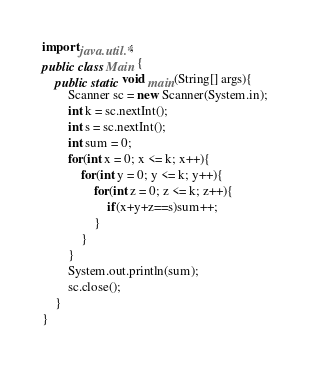<code> <loc_0><loc_0><loc_500><loc_500><_Java_>import java.util.*;
public class Main {
    public static void main(String[] args){
        Scanner sc = new Scanner(System.in);
        int k = sc.nextInt();
        int s = sc.nextInt();
        int sum = 0;
        for(int x = 0; x <= k; x++){
            for(int y = 0; y <= k; y++){
                for(int z = 0; z <= k; z++){
                    if(x+y+z==s)sum++;
                }
            }
        }
        System.out.println(sum);
        sc.close();
    }
}</code> 